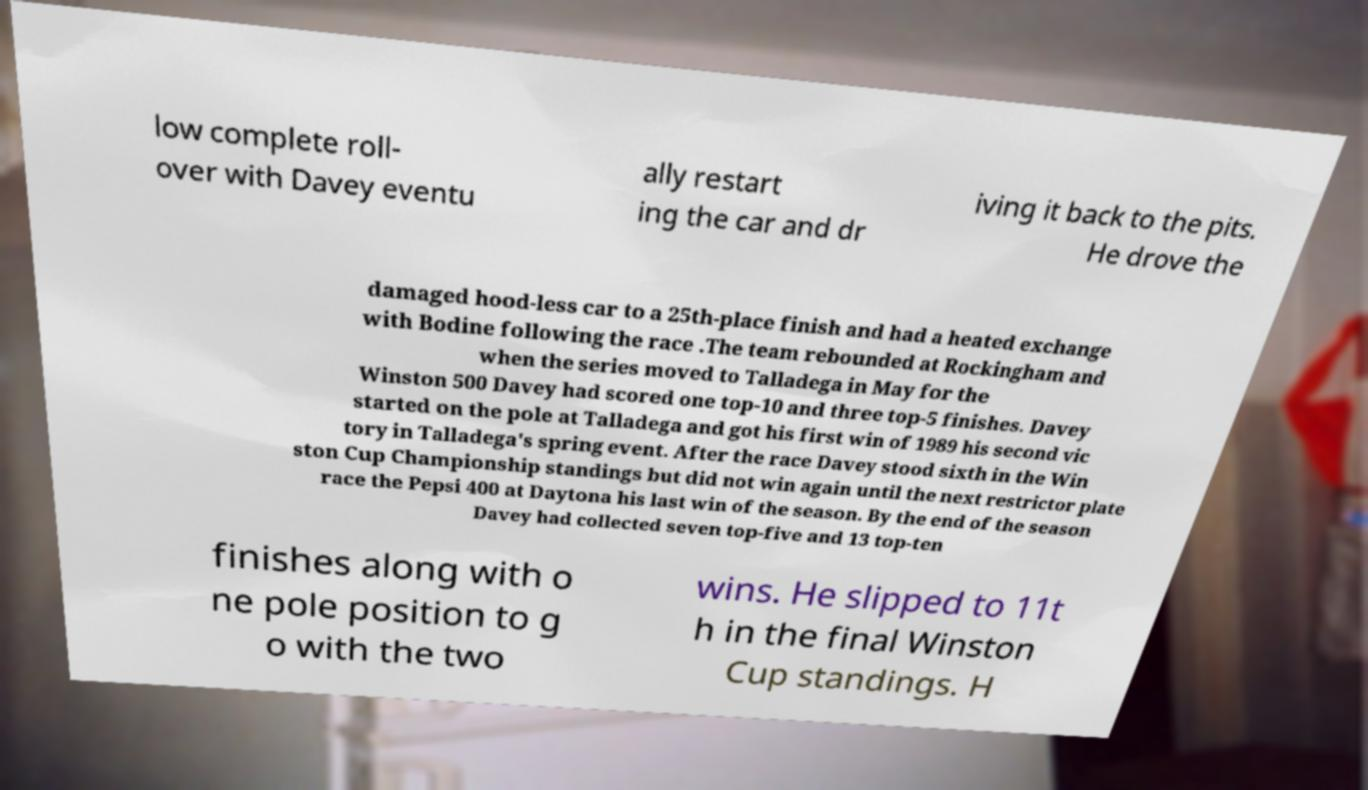Please identify and transcribe the text found in this image. low complete roll- over with Davey eventu ally restart ing the car and dr iving it back to the pits. He drove the damaged hood-less car to a 25th-place finish and had a heated exchange with Bodine following the race .The team rebounded at Rockingham and when the series moved to Talladega in May for the Winston 500 Davey had scored one top-10 and three top-5 finishes. Davey started on the pole at Talladega and got his first win of 1989 his second vic tory in Talladega's spring event. After the race Davey stood sixth in the Win ston Cup Championship standings but did not win again until the next restrictor plate race the Pepsi 400 at Daytona his last win of the season. By the end of the season Davey had collected seven top-five and 13 top-ten finishes along with o ne pole position to g o with the two wins. He slipped to 11t h in the final Winston Cup standings. H 